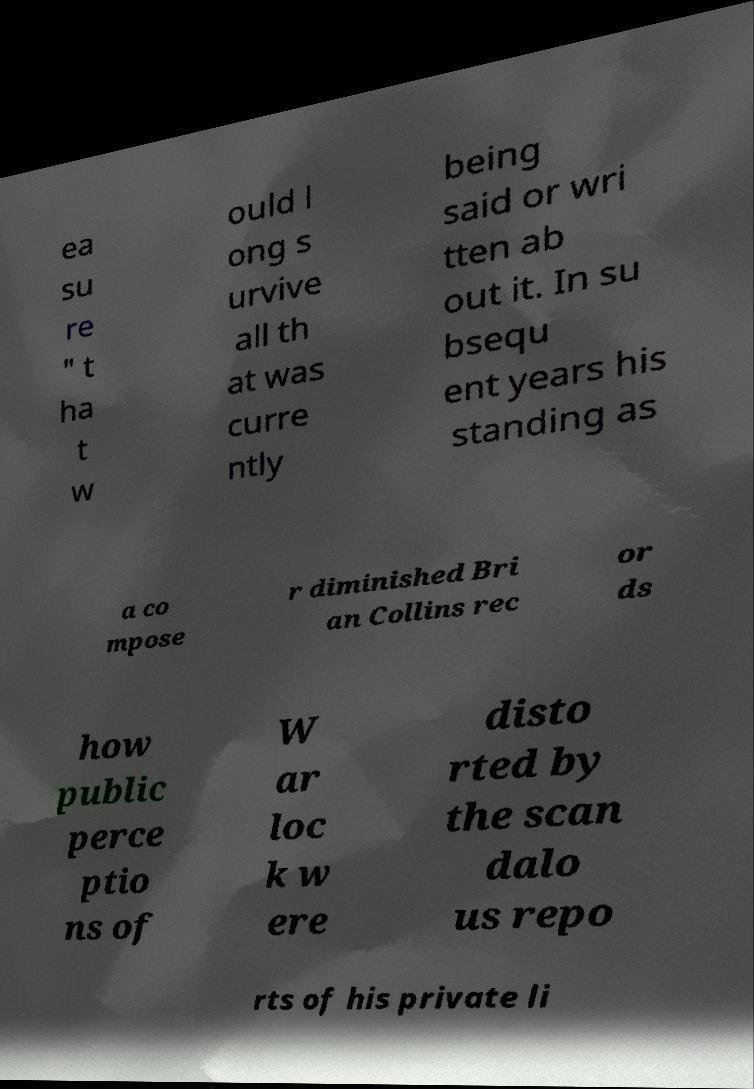What messages or text are displayed in this image? I need them in a readable, typed format. ea su re " t ha t w ould l ong s urvive all th at was curre ntly being said or wri tten ab out it. In su bsequ ent years his standing as a co mpose r diminished Bri an Collins rec or ds how public perce ptio ns of W ar loc k w ere disto rted by the scan dalo us repo rts of his private li 